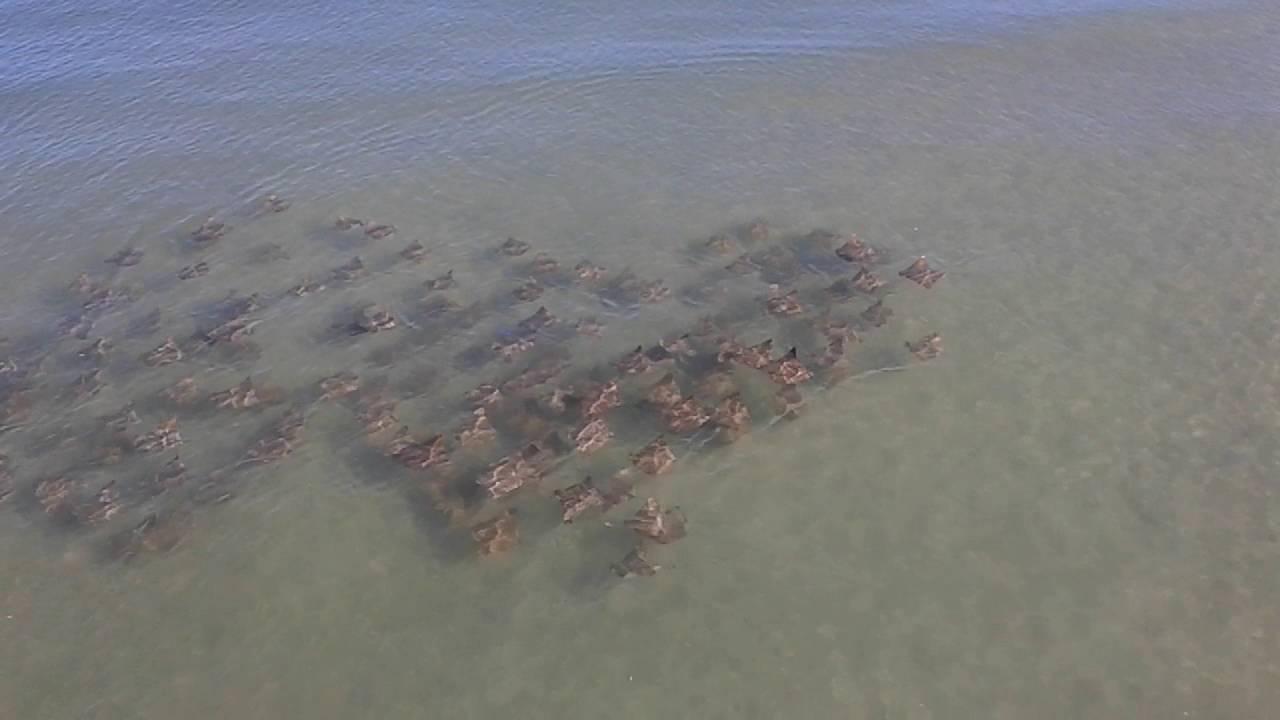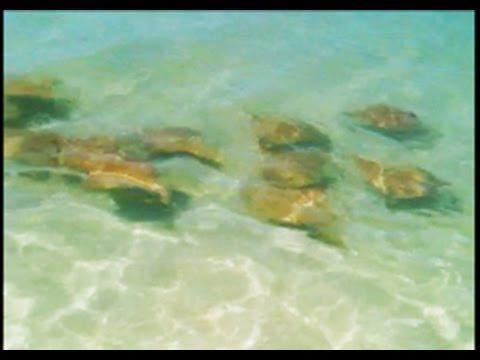The first image is the image on the left, the second image is the image on the right. Considering the images on both sides, is "An image shows one stingray with spots on its skin." valid? Answer yes or no. No. 